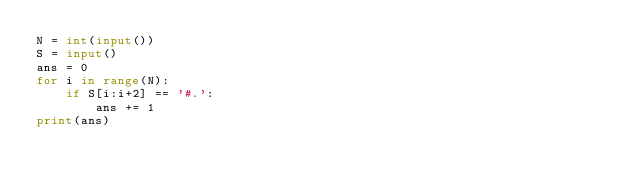Convert code to text. <code><loc_0><loc_0><loc_500><loc_500><_Python_>N = int(input())
S = input()
ans = 0
for i in range(N):
    if S[i:i+2] == '#.':
        ans += 1
print(ans)
</code> 